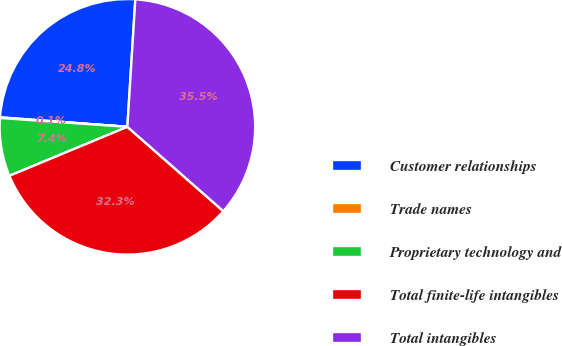Convert chart. <chart><loc_0><loc_0><loc_500><loc_500><pie_chart><fcel>Customer relationships<fcel>Trade names<fcel>Proprietary technology and<fcel>Total finite-life intangibles<fcel>Total intangibles<nl><fcel>24.8%<fcel>0.08%<fcel>7.37%<fcel>32.26%<fcel>35.48%<nl></chart> 